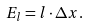Convert formula to latex. <formula><loc_0><loc_0><loc_500><loc_500>E _ { l } = l \cdot \Delta x .</formula> 